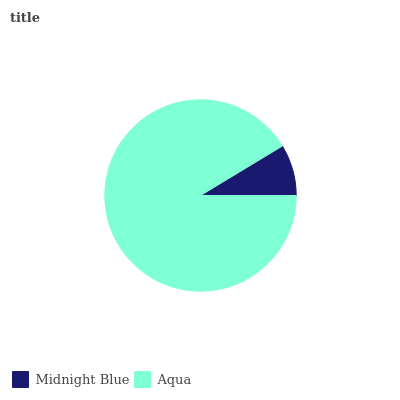Is Midnight Blue the minimum?
Answer yes or no. Yes. Is Aqua the maximum?
Answer yes or no. Yes. Is Aqua the minimum?
Answer yes or no. No. Is Aqua greater than Midnight Blue?
Answer yes or no. Yes. Is Midnight Blue less than Aqua?
Answer yes or no. Yes. Is Midnight Blue greater than Aqua?
Answer yes or no. No. Is Aqua less than Midnight Blue?
Answer yes or no. No. Is Aqua the high median?
Answer yes or no. Yes. Is Midnight Blue the low median?
Answer yes or no. Yes. Is Midnight Blue the high median?
Answer yes or no. No. Is Aqua the low median?
Answer yes or no. No. 